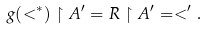<formula> <loc_0><loc_0><loc_500><loc_500>g ( < ^ { * } ) \upharpoonright A ^ { \prime } = R \upharpoonright A ^ { \prime } = < ^ { \prime } .</formula> 